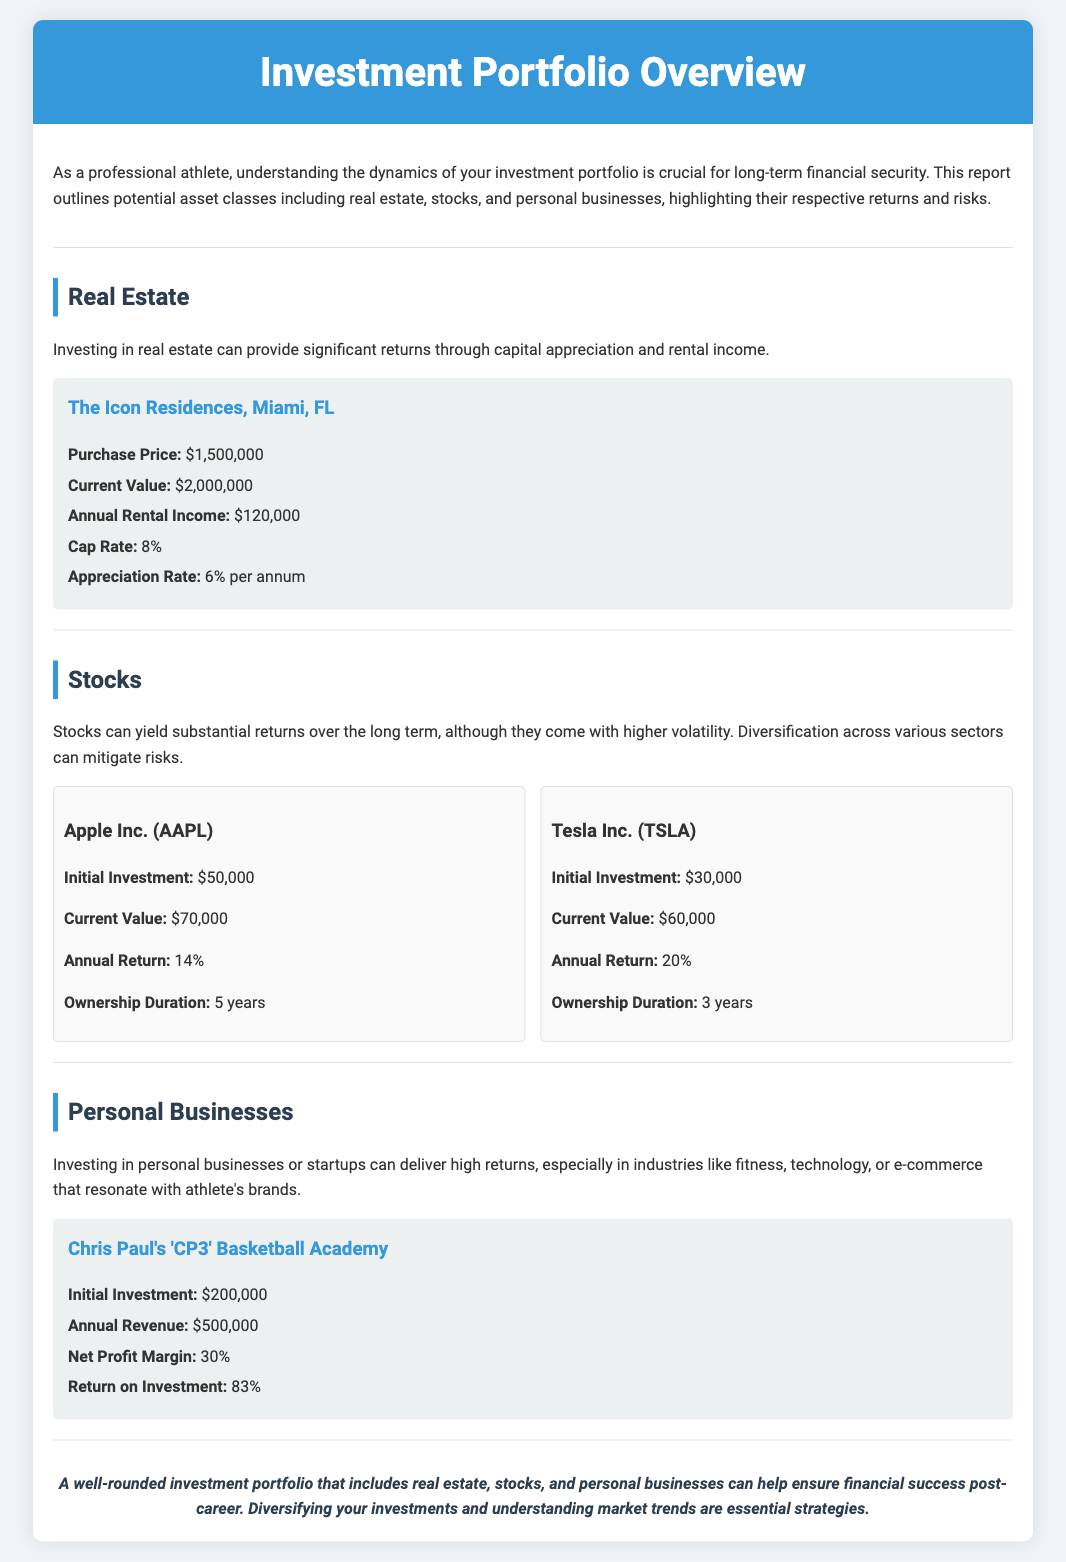What is the purchase price of The Icon Residences? The purchase price is specified in the document as $1,500,000.
Answer: $1,500,000 What is the annual return for Tesla Inc.? The document indicates that Tesla Inc. has an annual return of 20%.
Answer: 20% What is the appreciation rate for The Icon Residences? The appreciation rate is mentioned as 6% per annum in the report.
Answer: 6% per annum What is the net profit margin for Chris Paul's Basketball Academy? The net profit margin is specified in the document as 30%.
Answer: 30% What is the return on investment for Chris Paul's Basketball Academy? The document provides the return on investment as 83%.
Answer: 83% What is the current value of Apple Inc. stock? The current value is provided as $70,000 in the section about Apple Inc.
Answer: $70,000 How long has the investment in Tesla been held? The document states that Tesla Inc. has been owned for 3 years.
Answer: 3 years What type of asset class is highlighted for potential high returns related to personal brand? The report mentions personal businesses as an asset class that can deliver high returns.
Answer: Personal businesses What is the annual rental income from The Icon Residences? The annual rental income is indicated as $120,000 in the document.
Answer: $120,000 